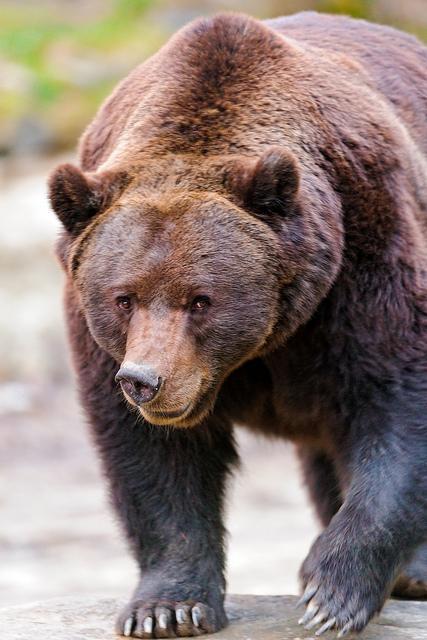How many people are wearing glasses?
Give a very brief answer. 0. 